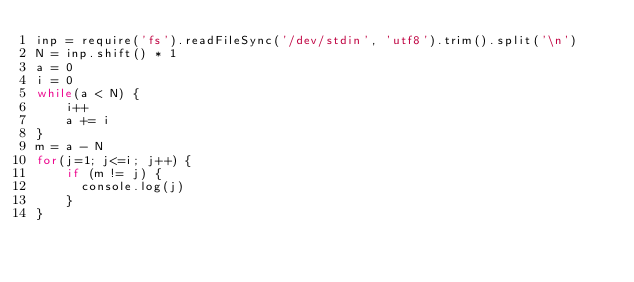Convert code to text. <code><loc_0><loc_0><loc_500><loc_500><_JavaScript_>inp = require('fs').readFileSync('/dev/stdin', 'utf8').trim().split('\n')
N = inp.shift() * 1
a = 0
i = 0
while(a < N) {
    i++
    a += i
}
m = a - N
for(j=1; j<=i; j++) {
    if (m != j) {
      console.log(j)
    }
}</code> 